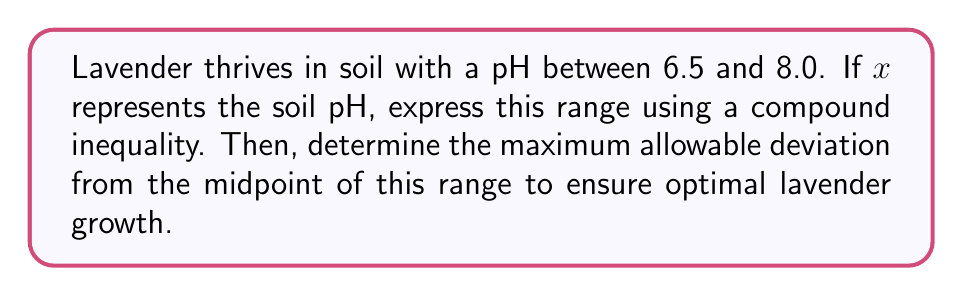Give your solution to this math problem. 1) First, let's express the pH range as a compound inequality:
   $$6.5 \leq x \leq 8.0$$

2) To find the midpoint of this range:
   $$\text{Midpoint} = \frac{6.5 + 8.0}{2} = \frac{14.5}{2} = 7.25$$

3) Now, we need to find the maximum deviation from this midpoint that still keeps us within the optimal range. This is the smaller of:
   - Distance from midpoint to lower bound: $7.25 - 6.5 = 0.75$
   - Distance from midpoint to upper bound: $8.0 - 7.25 = 0.75$

4) Both distances are equal, so the maximum allowable deviation is 0.75.

5) We can express this as an inequality:
   $$|x - 7.25| \leq 0.75$$

This inequality represents the optimal range for lavender growth, centered around the midpoint of 7.25 with a maximum deviation of 0.75 in either direction.
Answer: $|x - 7.25| \leq 0.75$ 